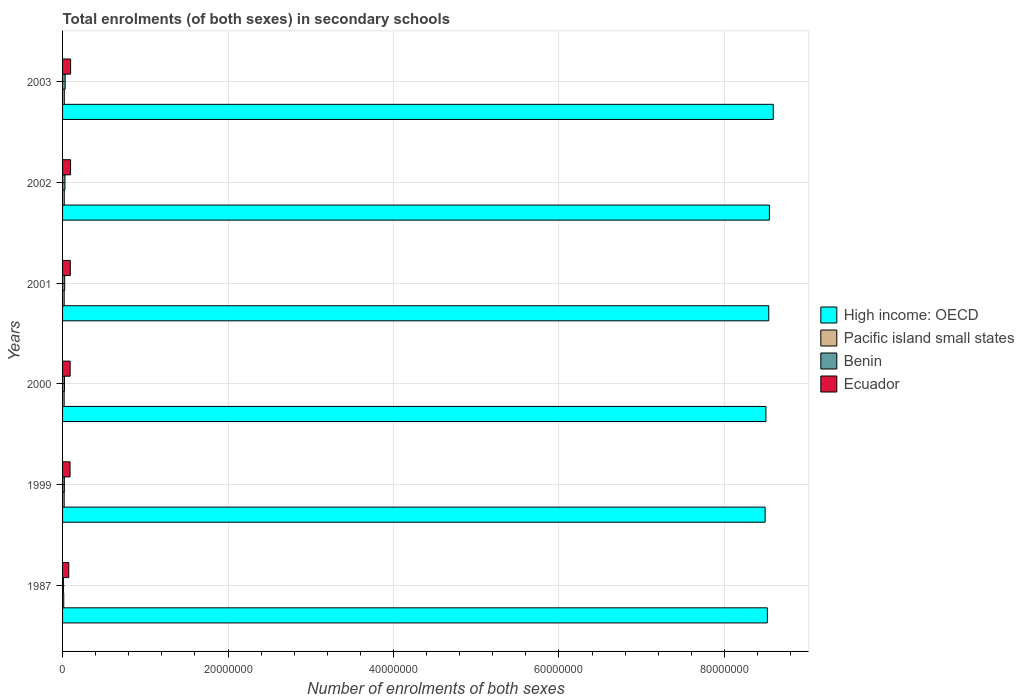How many different coloured bars are there?
Keep it short and to the point. 4. How many groups of bars are there?
Provide a short and direct response. 6. Are the number of bars on each tick of the Y-axis equal?
Give a very brief answer. Yes. How many bars are there on the 6th tick from the top?
Give a very brief answer. 4. How many bars are there on the 6th tick from the bottom?
Offer a terse response. 4. What is the label of the 6th group of bars from the top?
Give a very brief answer. 1987. What is the number of enrolments in secondary schools in Ecuador in 2003?
Ensure brevity in your answer.  9.73e+05. Across all years, what is the maximum number of enrolments in secondary schools in Pacific island small states?
Provide a short and direct response. 2.08e+05. Across all years, what is the minimum number of enrolments in secondary schools in Benin?
Make the answer very short. 1.02e+05. What is the total number of enrolments in secondary schools in Pacific island small states in the graph?
Make the answer very short. 1.13e+06. What is the difference between the number of enrolments in secondary schools in Pacific island small states in 1987 and that in 2003?
Keep it short and to the point. -6.49e+04. What is the difference between the number of enrolments in secondary schools in High income: OECD in 2001 and the number of enrolments in secondary schools in Ecuador in 2003?
Provide a succinct answer. 8.44e+07. What is the average number of enrolments in secondary schools in Benin per year?
Offer a very short reply. 2.34e+05. In the year 2000, what is the difference between the number of enrolments in secondary schools in Ecuador and number of enrolments in secondary schools in Pacific island small states?
Provide a short and direct response. 7.27e+05. What is the ratio of the number of enrolments in secondary schools in Benin in 2002 to that in 2003?
Provide a succinct answer. 0.92. Is the number of enrolments in secondary schools in Benin in 1987 less than that in 2000?
Ensure brevity in your answer.  Yes. What is the difference between the highest and the second highest number of enrolments in secondary schools in High income: OECD?
Make the answer very short. 4.66e+05. What is the difference between the highest and the lowest number of enrolments in secondary schools in High income: OECD?
Offer a very short reply. 9.82e+05. In how many years, is the number of enrolments in secondary schools in Pacific island small states greater than the average number of enrolments in secondary schools in Pacific island small states taken over all years?
Ensure brevity in your answer.  5. Is the sum of the number of enrolments in secondary schools in Ecuador in 2000 and 2001 greater than the maximum number of enrolments in secondary schools in Pacific island small states across all years?
Give a very brief answer. Yes. What does the 3rd bar from the top in 2001 represents?
Provide a short and direct response. Pacific island small states. What does the 1st bar from the bottom in 2000 represents?
Give a very brief answer. High income: OECD. Are all the bars in the graph horizontal?
Your answer should be very brief. Yes. How many years are there in the graph?
Ensure brevity in your answer.  6. How are the legend labels stacked?
Provide a succinct answer. Vertical. What is the title of the graph?
Offer a very short reply. Total enrolments (of both sexes) in secondary schools. What is the label or title of the X-axis?
Provide a short and direct response. Number of enrolments of both sexes. What is the Number of enrolments of both sexes of High income: OECD in 1987?
Your response must be concise. 8.52e+07. What is the Number of enrolments of both sexes of Pacific island small states in 1987?
Your answer should be compact. 1.43e+05. What is the Number of enrolments of both sexes of Benin in 1987?
Give a very brief answer. 1.02e+05. What is the Number of enrolments of both sexes in Ecuador in 1987?
Make the answer very short. 7.50e+05. What is the Number of enrolments of both sexes in High income: OECD in 1999?
Provide a short and direct response. 8.49e+07. What is the Number of enrolments of both sexes of Pacific island small states in 1999?
Your answer should be compact. 1.93e+05. What is the Number of enrolments of both sexes in Benin in 1999?
Provide a succinct answer. 2.13e+05. What is the Number of enrolments of both sexes of Ecuador in 1999?
Your answer should be very brief. 9.04e+05. What is the Number of enrolments of both sexes of High income: OECD in 2000?
Ensure brevity in your answer.  8.50e+07. What is the Number of enrolments of both sexes in Pacific island small states in 2000?
Provide a short and direct response. 1.91e+05. What is the Number of enrolments of both sexes of Benin in 2000?
Provide a succinct answer. 2.29e+05. What is the Number of enrolments of both sexes in Ecuador in 2000?
Provide a short and direct response. 9.17e+05. What is the Number of enrolments of both sexes in High income: OECD in 2001?
Keep it short and to the point. 8.54e+07. What is the Number of enrolments of both sexes of Pacific island small states in 2001?
Provide a succinct answer. 1.94e+05. What is the Number of enrolments of both sexes of Benin in 2001?
Your answer should be very brief. 2.57e+05. What is the Number of enrolments of both sexes in Ecuador in 2001?
Provide a short and direct response. 9.36e+05. What is the Number of enrolments of both sexes in High income: OECD in 2002?
Your response must be concise. 8.54e+07. What is the Number of enrolments of both sexes in Pacific island small states in 2002?
Your response must be concise. 2.03e+05. What is the Number of enrolments of both sexes of Benin in 2002?
Provide a short and direct response. 2.87e+05. What is the Number of enrolments of both sexes in Ecuador in 2002?
Offer a terse response. 9.66e+05. What is the Number of enrolments of both sexes in High income: OECD in 2003?
Provide a succinct answer. 8.59e+07. What is the Number of enrolments of both sexes in Pacific island small states in 2003?
Your response must be concise. 2.08e+05. What is the Number of enrolments of both sexes of Benin in 2003?
Your answer should be very brief. 3.12e+05. What is the Number of enrolments of both sexes in Ecuador in 2003?
Offer a terse response. 9.73e+05. Across all years, what is the maximum Number of enrolments of both sexes of High income: OECD?
Ensure brevity in your answer.  8.59e+07. Across all years, what is the maximum Number of enrolments of both sexes of Pacific island small states?
Your answer should be compact. 2.08e+05. Across all years, what is the maximum Number of enrolments of both sexes in Benin?
Offer a terse response. 3.12e+05. Across all years, what is the maximum Number of enrolments of both sexes of Ecuador?
Offer a very short reply. 9.73e+05. Across all years, what is the minimum Number of enrolments of both sexes in High income: OECD?
Offer a terse response. 8.49e+07. Across all years, what is the minimum Number of enrolments of both sexes in Pacific island small states?
Give a very brief answer. 1.43e+05. Across all years, what is the minimum Number of enrolments of both sexes of Benin?
Make the answer very short. 1.02e+05. Across all years, what is the minimum Number of enrolments of both sexes in Ecuador?
Your response must be concise. 7.50e+05. What is the total Number of enrolments of both sexes of High income: OECD in the graph?
Make the answer very short. 5.12e+08. What is the total Number of enrolments of both sexes of Pacific island small states in the graph?
Give a very brief answer. 1.13e+06. What is the total Number of enrolments of both sexes of Benin in the graph?
Provide a short and direct response. 1.40e+06. What is the total Number of enrolments of both sexes of Ecuador in the graph?
Your answer should be very brief. 5.45e+06. What is the difference between the Number of enrolments of both sexes of High income: OECD in 1987 and that in 1999?
Offer a very short reply. 2.66e+05. What is the difference between the Number of enrolments of both sexes of Pacific island small states in 1987 and that in 1999?
Ensure brevity in your answer.  -5.00e+04. What is the difference between the Number of enrolments of both sexes in Benin in 1987 and that in 1999?
Keep it short and to the point. -1.11e+05. What is the difference between the Number of enrolments of both sexes in Ecuador in 1987 and that in 1999?
Your answer should be very brief. -1.54e+05. What is the difference between the Number of enrolments of both sexes of High income: OECD in 1987 and that in 2000?
Provide a short and direct response. 1.71e+05. What is the difference between the Number of enrolments of both sexes in Pacific island small states in 1987 and that in 2000?
Your answer should be very brief. -4.80e+04. What is the difference between the Number of enrolments of both sexes in Benin in 1987 and that in 2000?
Offer a very short reply. -1.27e+05. What is the difference between the Number of enrolments of both sexes in Ecuador in 1987 and that in 2000?
Ensure brevity in your answer.  -1.67e+05. What is the difference between the Number of enrolments of both sexes of High income: OECD in 1987 and that in 2001?
Your answer should be very brief. -1.72e+05. What is the difference between the Number of enrolments of both sexes of Pacific island small states in 1987 and that in 2001?
Your answer should be very brief. -5.18e+04. What is the difference between the Number of enrolments of both sexes in Benin in 1987 and that in 2001?
Offer a terse response. -1.55e+05. What is the difference between the Number of enrolments of both sexes in Ecuador in 1987 and that in 2001?
Keep it short and to the point. -1.86e+05. What is the difference between the Number of enrolments of both sexes of High income: OECD in 1987 and that in 2002?
Ensure brevity in your answer.  -2.49e+05. What is the difference between the Number of enrolments of both sexes in Pacific island small states in 1987 and that in 2002?
Provide a succinct answer. -6.06e+04. What is the difference between the Number of enrolments of both sexes of Benin in 1987 and that in 2002?
Your answer should be compact. -1.85e+05. What is the difference between the Number of enrolments of both sexes in Ecuador in 1987 and that in 2002?
Provide a short and direct response. -2.16e+05. What is the difference between the Number of enrolments of both sexes in High income: OECD in 1987 and that in 2003?
Ensure brevity in your answer.  -7.16e+05. What is the difference between the Number of enrolments of both sexes of Pacific island small states in 1987 and that in 2003?
Keep it short and to the point. -6.49e+04. What is the difference between the Number of enrolments of both sexes in Benin in 1987 and that in 2003?
Provide a succinct answer. -2.10e+05. What is the difference between the Number of enrolments of both sexes of Ecuador in 1987 and that in 2003?
Give a very brief answer. -2.23e+05. What is the difference between the Number of enrolments of both sexes of High income: OECD in 1999 and that in 2000?
Provide a succinct answer. -9.49e+04. What is the difference between the Number of enrolments of both sexes in Pacific island small states in 1999 and that in 2000?
Provide a short and direct response. 1919. What is the difference between the Number of enrolments of both sexes of Benin in 1999 and that in 2000?
Make the answer very short. -1.58e+04. What is the difference between the Number of enrolments of both sexes of Ecuador in 1999 and that in 2000?
Make the answer very short. -1.37e+04. What is the difference between the Number of enrolments of both sexes of High income: OECD in 1999 and that in 2001?
Provide a short and direct response. -4.38e+05. What is the difference between the Number of enrolments of both sexes in Pacific island small states in 1999 and that in 2001?
Keep it short and to the point. -1878.09. What is the difference between the Number of enrolments of both sexes of Benin in 1999 and that in 2001?
Provide a short and direct response. -4.33e+04. What is the difference between the Number of enrolments of both sexes in Ecuador in 1999 and that in 2001?
Your answer should be very brief. -3.28e+04. What is the difference between the Number of enrolments of both sexes of High income: OECD in 1999 and that in 2002?
Provide a succinct answer. -5.15e+05. What is the difference between the Number of enrolments of both sexes of Pacific island small states in 1999 and that in 2002?
Give a very brief answer. -1.07e+04. What is the difference between the Number of enrolments of both sexes of Benin in 1999 and that in 2002?
Your answer should be very brief. -7.38e+04. What is the difference between the Number of enrolments of both sexes in Ecuador in 1999 and that in 2002?
Offer a terse response. -6.28e+04. What is the difference between the Number of enrolments of both sexes in High income: OECD in 1999 and that in 2003?
Your answer should be compact. -9.82e+05. What is the difference between the Number of enrolments of both sexes of Pacific island small states in 1999 and that in 2003?
Provide a succinct answer. -1.50e+04. What is the difference between the Number of enrolments of both sexes of Benin in 1999 and that in 2003?
Offer a very short reply. -9.90e+04. What is the difference between the Number of enrolments of both sexes of Ecuador in 1999 and that in 2003?
Offer a terse response. -6.92e+04. What is the difference between the Number of enrolments of both sexes in High income: OECD in 2000 and that in 2001?
Offer a terse response. -3.43e+05. What is the difference between the Number of enrolments of both sexes in Pacific island small states in 2000 and that in 2001?
Your answer should be very brief. -3797.09. What is the difference between the Number of enrolments of both sexes in Benin in 2000 and that in 2001?
Offer a terse response. -2.75e+04. What is the difference between the Number of enrolments of both sexes of Ecuador in 2000 and that in 2001?
Keep it short and to the point. -1.92e+04. What is the difference between the Number of enrolments of both sexes in High income: OECD in 2000 and that in 2002?
Make the answer very short. -4.20e+05. What is the difference between the Number of enrolments of both sexes of Pacific island small states in 2000 and that in 2002?
Make the answer very short. -1.26e+04. What is the difference between the Number of enrolments of both sexes in Benin in 2000 and that in 2002?
Make the answer very short. -5.81e+04. What is the difference between the Number of enrolments of both sexes of Ecuador in 2000 and that in 2002?
Provide a succinct answer. -4.91e+04. What is the difference between the Number of enrolments of both sexes in High income: OECD in 2000 and that in 2003?
Give a very brief answer. -8.87e+05. What is the difference between the Number of enrolments of both sexes in Pacific island small states in 2000 and that in 2003?
Give a very brief answer. -1.69e+04. What is the difference between the Number of enrolments of both sexes in Benin in 2000 and that in 2003?
Offer a very short reply. -8.32e+04. What is the difference between the Number of enrolments of both sexes in Ecuador in 2000 and that in 2003?
Ensure brevity in your answer.  -5.55e+04. What is the difference between the Number of enrolments of both sexes of High income: OECD in 2001 and that in 2002?
Provide a succinct answer. -7.73e+04. What is the difference between the Number of enrolments of both sexes in Pacific island small states in 2001 and that in 2002?
Provide a short and direct response. -8784.14. What is the difference between the Number of enrolments of both sexes in Benin in 2001 and that in 2002?
Your answer should be very brief. -3.05e+04. What is the difference between the Number of enrolments of both sexes in Ecuador in 2001 and that in 2002?
Make the answer very short. -3.00e+04. What is the difference between the Number of enrolments of both sexes of High income: OECD in 2001 and that in 2003?
Make the answer very short. -5.44e+05. What is the difference between the Number of enrolments of both sexes in Pacific island small states in 2001 and that in 2003?
Your answer should be compact. -1.31e+04. What is the difference between the Number of enrolments of both sexes in Benin in 2001 and that in 2003?
Your answer should be compact. -5.57e+04. What is the difference between the Number of enrolments of both sexes of Ecuador in 2001 and that in 2003?
Keep it short and to the point. -3.64e+04. What is the difference between the Number of enrolments of both sexes in High income: OECD in 2002 and that in 2003?
Offer a terse response. -4.66e+05. What is the difference between the Number of enrolments of both sexes of Pacific island small states in 2002 and that in 2003?
Offer a very short reply. -4304.56. What is the difference between the Number of enrolments of both sexes in Benin in 2002 and that in 2003?
Your response must be concise. -2.51e+04. What is the difference between the Number of enrolments of both sexes in Ecuador in 2002 and that in 2003?
Offer a very short reply. -6415. What is the difference between the Number of enrolments of both sexes of High income: OECD in 1987 and the Number of enrolments of both sexes of Pacific island small states in 1999?
Make the answer very short. 8.50e+07. What is the difference between the Number of enrolments of both sexes in High income: OECD in 1987 and the Number of enrolments of both sexes in Benin in 1999?
Your answer should be very brief. 8.50e+07. What is the difference between the Number of enrolments of both sexes in High income: OECD in 1987 and the Number of enrolments of both sexes in Ecuador in 1999?
Give a very brief answer. 8.43e+07. What is the difference between the Number of enrolments of both sexes in Pacific island small states in 1987 and the Number of enrolments of both sexes in Benin in 1999?
Your answer should be very brief. -7.09e+04. What is the difference between the Number of enrolments of both sexes in Pacific island small states in 1987 and the Number of enrolments of both sexes in Ecuador in 1999?
Your response must be concise. -7.61e+05. What is the difference between the Number of enrolments of both sexes of Benin in 1987 and the Number of enrolments of both sexes of Ecuador in 1999?
Give a very brief answer. -8.01e+05. What is the difference between the Number of enrolments of both sexes in High income: OECD in 1987 and the Number of enrolments of both sexes in Pacific island small states in 2000?
Ensure brevity in your answer.  8.50e+07. What is the difference between the Number of enrolments of both sexes of High income: OECD in 1987 and the Number of enrolments of both sexes of Benin in 2000?
Your answer should be compact. 8.50e+07. What is the difference between the Number of enrolments of both sexes of High income: OECD in 1987 and the Number of enrolments of both sexes of Ecuador in 2000?
Give a very brief answer. 8.43e+07. What is the difference between the Number of enrolments of both sexes in Pacific island small states in 1987 and the Number of enrolments of both sexes in Benin in 2000?
Make the answer very short. -8.66e+04. What is the difference between the Number of enrolments of both sexes of Pacific island small states in 1987 and the Number of enrolments of both sexes of Ecuador in 2000?
Your answer should be compact. -7.75e+05. What is the difference between the Number of enrolments of both sexes of Benin in 1987 and the Number of enrolments of both sexes of Ecuador in 2000?
Give a very brief answer. -8.15e+05. What is the difference between the Number of enrolments of both sexes of High income: OECD in 1987 and the Number of enrolments of both sexes of Pacific island small states in 2001?
Offer a very short reply. 8.50e+07. What is the difference between the Number of enrolments of both sexes of High income: OECD in 1987 and the Number of enrolments of both sexes of Benin in 2001?
Ensure brevity in your answer.  8.49e+07. What is the difference between the Number of enrolments of both sexes in High income: OECD in 1987 and the Number of enrolments of both sexes in Ecuador in 2001?
Ensure brevity in your answer.  8.43e+07. What is the difference between the Number of enrolments of both sexes in Pacific island small states in 1987 and the Number of enrolments of both sexes in Benin in 2001?
Your response must be concise. -1.14e+05. What is the difference between the Number of enrolments of both sexes of Pacific island small states in 1987 and the Number of enrolments of both sexes of Ecuador in 2001?
Offer a terse response. -7.94e+05. What is the difference between the Number of enrolments of both sexes in Benin in 1987 and the Number of enrolments of both sexes in Ecuador in 2001?
Offer a very short reply. -8.34e+05. What is the difference between the Number of enrolments of both sexes of High income: OECD in 1987 and the Number of enrolments of both sexes of Pacific island small states in 2002?
Make the answer very short. 8.50e+07. What is the difference between the Number of enrolments of both sexes in High income: OECD in 1987 and the Number of enrolments of both sexes in Benin in 2002?
Your response must be concise. 8.49e+07. What is the difference between the Number of enrolments of both sexes in High income: OECD in 1987 and the Number of enrolments of both sexes in Ecuador in 2002?
Make the answer very short. 8.42e+07. What is the difference between the Number of enrolments of both sexes of Pacific island small states in 1987 and the Number of enrolments of both sexes of Benin in 2002?
Provide a succinct answer. -1.45e+05. What is the difference between the Number of enrolments of both sexes in Pacific island small states in 1987 and the Number of enrolments of both sexes in Ecuador in 2002?
Give a very brief answer. -8.24e+05. What is the difference between the Number of enrolments of both sexes in Benin in 1987 and the Number of enrolments of both sexes in Ecuador in 2002?
Ensure brevity in your answer.  -8.64e+05. What is the difference between the Number of enrolments of both sexes of High income: OECD in 1987 and the Number of enrolments of both sexes of Pacific island small states in 2003?
Offer a terse response. 8.50e+07. What is the difference between the Number of enrolments of both sexes of High income: OECD in 1987 and the Number of enrolments of both sexes of Benin in 2003?
Your answer should be compact. 8.49e+07. What is the difference between the Number of enrolments of both sexes of High income: OECD in 1987 and the Number of enrolments of both sexes of Ecuador in 2003?
Your response must be concise. 8.42e+07. What is the difference between the Number of enrolments of both sexes in Pacific island small states in 1987 and the Number of enrolments of both sexes in Benin in 2003?
Provide a succinct answer. -1.70e+05. What is the difference between the Number of enrolments of both sexes of Pacific island small states in 1987 and the Number of enrolments of both sexes of Ecuador in 2003?
Provide a succinct answer. -8.30e+05. What is the difference between the Number of enrolments of both sexes of Benin in 1987 and the Number of enrolments of both sexes of Ecuador in 2003?
Make the answer very short. -8.71e+05. What is the difference between the Number of enrolments of both sexes of High income: OECD in 1999 and the Number of enrolments of both sexes of Pacific island small states in 2000?
Offer a very short reply. 8.47e+07. What is the difference between the Number of enrolments of both sexes in High income: OECD in 1999 and the Number of enrolments of both sexes in Benin in 2000?
Your answer should be compact. 8.47e+07. What is the difference between the Number of enrolments of both sexes in High income: OECD in 1999 and the Number of enrolments of both sexes in Ecuador in 2000?
Keep it short and to the point. 8.40e+07. What is the difference between the Number of enrolments of both sexes in Pacific island small states in 1999 and the Number of enrolments of both sexes in Benin in 2000?
Your answer should be compact. -3.66e+04. What is the difference between the Number of enrolments of both sexes of Pacific island small states in 1999 and the Number of enrolments of both sexes of Ecuador in 2000?
Offer a very short reply. -7.25e+05. What is the difference between the Number of enrolments of both sexes in Benin in 1999 and the Number of enrolments of both sexes in Ecuador in 2000?
Give a very brief answer. -7.04e+05. What is the difference between the Number of enrolments of both sexes of High income: OECD in 1999 and the Number of enrolments of both sexes of Pacific island small states in 2001?
Offer a terse response. 8.47e+07. What is the difference between the Number of enrolments of both sexes of High income: OECD in 1999 and the Number of enrolments of both sexes of Benin in 2001?
Keep it short and to the point. 8.47e+07. What is the difference between the Number of enrolments of both sexes in High income: OECD in 1999 and the Number of enrolments of both sexes in Ecuador in 2001?
Your response must be concise. 8.40e+07. What is the difference between the Number of enrolments of both sexes of Pacific island small states in 1999 and the Number of enrolments of both sexes of Benin in 2001?
Offer a terse response. -6.42e+04. What is the difference between the Number of enrolments of both sexes in Pacific island small states in 1999 and the Number of enrolments of both sexes in Ecuador in 2001?
Your answer should be very brief. -7.44e+05. What is the difference between the Number of enrolments of both sexes in Benin in 1999 and the Number of enrolments of both sexes in Ecuador in 2001?
Your answer should be compact. -7.23e+05. What is the difference between the Number of enrolments of both sexes in High income: OECD in 1999 and the Number of enrolments of both sexes in Pacific island small states in 2002?
Provide a succinct answer. 8.47e+07. What is the difference between the Number of enrolments of both sexes of High income: OECD in 1999 and the Number of enrolments of both sexes of Benin in 2002?
Make the answer very short. 8.46e+07. What is the difference between the Number of enrolments of both sexes of High income: OECD in 1999 and the Number of enrolments of both sexes of Ecuador in 2002?
Your answer should be very brief. 8.40e+07. What is the difference between the Number of enrolments of both sexes of Pacific island small states in 1999 and the Number of enrolments of both sexes of Benin in 2002?
Make the answer very short. -9.47e+04. What is the difference between the Number of enrolments of both sexes of Pacific island small states in 1999 and the Number of enrolments of both sexes of Ecuador in 2002?
Give a very brief answer. -7.74e+05. What is the difference between the Number of enrolments of both sexes in Benin in 1999 and the Number of enrolments of both sexes in Ecuador in 2002?
Give a very brief answer. -7.53e+05. What is the difference between the Number of enrolments of both sexes of High income: OECD in 1999 and the Number of enrolments of both sexes of Pacific island small states in 2003?
Make the answer very short. 8.47e+07. What is the difference between the Number of enrolments of both sexes of High income: OECD in 1999 and the Number of enrolments of both sexes of Benin in 2003?
Give a very brief answer. 8.46e+07. What is the difference between the Number of enrolments of both sexes in High income: OECD in 1999 and the Number of enrolments of both sexes in Ecuador in 2003?
Make the answer very short. 8.39e+07. What is the difference between the Number of enrolments of both sexes of Pacific island small states in 1999 and the Number of enrolments of both sexes of Benin in 2003?
Keep it short and to the point. -1.20e+05. What is the difference between the Number of enrolments of both sexes of Pacific island small states in 1999 and the Number of enrolments of both sexes of Ecuador in 2003?
Your answer should be very brief. -7.80e+05. What is the difference between the Number of enrolments of both sexes of Benin in 1999 and the Number of enrolments of both sexes of Ecuador in 2003?
Your answer should be compact. -7.59e+05. What is the difference between the Number of enrolments of both sexes in High income: OECD in 2000 and the Number of enrolments of both sexes in Pacific island small states in 2001?
Ensure brevity in your answer.  8.48e+07. What is the difference between the Number of enrolments of both sexes of High income: OECD in 2000 and the Number of enrolments of both sexes of Benin in 2001?
Ensure brevity in your answer.  8.48e+07. What is the difference between the Number of enrolments of both sexes of High income: OECD in 2000 and the Number of enrolments of both sexes of Ecuador in 2001?
Give a very brief answer. 8.41e+07. What is the difference between the Number of enrolments of both sexes in Pacific island small states in 2000 and the Number of enrolments of both sexes in Benin in 2001?
Provide a succinct answer. -6.61e+04. What is the difference between the Number of enrolments of both sexes in Pacific island small states in 2000 and the Number of enrolments of both sexes in Ecuador in 2001?
Your response must be concise. -7.46e+05. What is the difference between the Number of enrolments of both sexes of Benin in 2000 and the Number of enrolments of both sexes of Ecuador in 2001?
Provide a succinct answer. -7.07e+05. What is the difference between the Number of enrolments of both sexes of High income: OECD in 2000 and the Number of enrolments of both sexes of Pacific island small states in 2002?
Give a very brief answer. 8.48e+07. What is the difference between the Number of enrolments of both sexes in High income: OECD in 2000 and the Number of enrolments of both sexes in Benin in 2002?
Your answer should be very brief. 8.47e+07. What is the difference between the Number of enrolments of both sexes of High income: OECD in 2000 and the Number of enrolments of both sexes of Ecuador in 2002?
Make the answer very short. 8.41e+07. What is the difference between the Number of enrolments of both sexes in Pacific island small states in 2000 and the Number of enrolments of both sexes in Benin in 2002?
Offer a very short reply. -9.66e+04. What is the difference between the Number of enrolments of both sexes in Pacific island small states in 2000 and the Number of enrolments of both sexes in Ecuador in 2002?
Your answer should be compact. -7.76e+05. What is the difference between the Number of enrolments of both sexes in Benin in 2000 and the Number of enrolments of both sexes in Ecuador in 2002?
Give a very brief answer. -7.37e+05. What is the difference between the Number of enrolments of both sexes in High income: OECD in 2000 and the Number of enrolments of both sexes in Pacific island small states in 2003?
Provide a short and direct response. 8.48e+07. What is the difference between the Number of enrolments of both sexes in High income: OECD in 2000 and the Number of enrolments of both sexes in Benin in 2003?
Your answer should be very brief. 8.47e+07. What is the difference between the Number of enrolments of both sexes of High income: OECD in 2000 and the Number of enrolments of both sexes of Ecuador in 2003?
Offer a terse response. 8.40e+07. What is the difference between the Number of enrolments of both sexes of Pacific island small states in 2000 and the Number of enrolments of both sexes of Benin in 2003?
Give a very brief answer. -1.22e+05. What is the difference between the Number of enrolments of both sexes of Pacific island small states in 2000 and the Number of enrolments of both sexes of Ecuador in 2003?
Your answer should be very brief. -7.82e+05. What is the difference between the Number of enrolments of both sexes of Benin in 2000 and the Number of enrolments of both sexes of Ecuador in 2003?
Provide a short and direct response. -7.44e+05. What is the difference between the Number of enrolments of both sexes in High income: OECD in 2001 and the Number of enrolments of both sexes in Pacific island small states in 2002?
Provide a succinct answer. 8.52e+07. What is the difference between the Number of enrolments of both sexes in High income: OECD in 2001 and the Number of enrolments of both sexes in Benin in 2002?
Your answer should be compact. 8.51e+07. What is the difference between the Number of enrolments of both sexes in High income: OECD in 2001 and the Number of enrolments of both sexes in Ecuador in 2002?
Provide a short and direct response. 8.44e+07. What is the difference between the Number of enrolments of both sexes of Pacific island small states in 2001 and the Number of enrolments of both sexes of Benin in 2002?
Ensure brevity in your answer.  -9.28e+04. What is the difference between the Number of enrolments of both sexes of Pacific island small states in 2001 and the Number of enrolments of both sexes of Ecuador in 2002?
Ensure brevity in your answer.  -7.72e+05. What is the difference between the Number of enrolments of both sexes of Benin in 2001 and the Number of enrolments of both sexes of Ecuador in 2002?
Offer a terse response. -7.10e+05. What is the difference between the Number of enrolments of both sexes of High income: OECD in 2001 and the Number of enrolments of both sexes of Pacific island small states in 2003?
Your answer should be very brief. 8.52e+07. What is the difference between the Number of enrolments of both sexes in High income: OECD in 2001 and the Number of enrolments of both sexes in Benin in 2003?
Give a very brief answer. 8.50e+07. What is the difference between the Number of enrolments of both sexes in High income: OECD in 2001 and the Number of enrolments of both sexes in Ecuador in 2003?
Provide a succinct answer. 8.44e+07. What is the difference between the Number of enrolments of both sexes in Pacific island small states in 2001 and the Number of enrolments of both sexes in Benin in 2003?
Provide a succinct answer. -1.18e+05. What is the difference between the Number of enrolments of both sexes of Pacific island small states in 2001 and the Number of enrolments of both sexes of Ecuador in 2003?
Offer a very short reply. -7.78e+05. What is the difference between the Number of enrolments of both sexes of Benin in 2001 and the Number of enrolments of both sexes of Ecuador in 2003?
Your answer should be very brief. -7.16e+05. What is the difference between the Number of enrolments of both sexes in High income: OECD in 2002 and the Number of enrolments of both sexes in Pacific island small states in 2003?
Ensure brevity in your answer.  8.52e+07. What is the difference between the Number of enrolments of both sexes of High income: OECD in 2002 and the Number of enrolments of both sexes of Benin in 2003?
Your response must be concise. 8.51e+07. What is the difference between the Number of enrolments of both sexes in High income: OECD in 2002 and the Number of enrolments of both sexes in Ecuador in 2003?
Offer a very short reply. 8.45e+07. What is the difference between the Number of enrolments of both sexes of Pacific island small states in 2002 and the Number of enrolments of both sexes of Benin in 2003?
Your answer should be compact. -1.09e+05. What is the difference between the Number of enrolments of both sexes in Pacific island small states in 2002 and the Number of enrolments of both sexes in Ecuador in 2003?
Ensure brevity in your answer.  -7.70e+05. What is the difference between the Number of enrolments of both sexes in Benin in 2002 and the Number of enrolments of both sexes in Ecuador in 2003?
Your response must be concise. -6.85e+05. What is the average Number of enrolments of both sexes of High income: OECD per year?
Make the answer very short. 8.53e+07. What is the average Number of enrolments of both sexes of Pacific island small states per year?
Offer a terse response. 1.89e+05. What is the average Number of enrolments of both sexes of Benin per year?
Your answer should be very brief. 2.34e+05. What is the average Number of enrolments of both sexes in Ecuador per year?
Ensure brevity in your answer.  9.08e+05. In the year 1987, what is the difference between the Number of enrolments of both sexes in High income: OECD and Number of enrolments of both sexes in Pacific island small states?
Make the answer very short. 8.50e+07. In the year 1987, what is the difference between the Number of enrolments of both sexes of High income: OECD and Number of enrolments of both sexes of Benin?
Give a very brief answer. 8.51e+07. In the year 1987, what is the difference between the Number of enrolments of both sexes of High income: OECD and Number of enrolments of both sexes of Ecuador?
Offer a terse response. 8.44e+07. In the year 1987, what is the difference between the Number of enrolments of both sexes in Pacific island small states and Number of enrolments of both sexes in Benin?
Provide a succinct answer. 4.04e+04. In the year 1987, what is the difference between the Number of enrolments of both sexes in Pacific island small states and Number of enrolments of both sexes in Ecuador?
Ensure brevity in your answer.  -6.07e+05. In the year 1987, what is the difference between the Number of enrolments of both sexes in Benin and Number of enrolments of both sexes in Ecuador?
Give a very brief answer. -6.48e+05. In the year 1999, what is the difference between the Number of enrolments of both sexes of High income: OECD and Number of enrolments of both sexes of Pacific island small states?
Provide a short and direct response. 8.47e+07. In the year 1999, what is the difference between the Number of enrolments of both sexes in High income: OECD and Number of enrolments of both sexes in Benin?
Keep it short and to the point. 8.47e+07. In the year 1999, what is the difference between the Number of enrolments of both sexes in High income: OECD and Number of enrolments of both sexes in Ecuador?
Make the answer very short. 8.40e+07. In the year 1999, what is the difference between the Number of enrolments of both sexes in Pacific island small states and Number of enrolments of both sexes in Benin?
Make the answer very short. -2.09e+04. In the year 1999, what is the difference between the Number of enrolments of both sexes of Pacific island small states and Number of enrolments of both sexes of Ecuador?
Offer a terse response. -7.11e+05. In the year 1999, what is the difference between the Number of enrolments of both sexes of Benin and Number of enrolments of both sexes of Ecuador?
Offer a terse response. -6.90e+05. In the year 2000, what is the difference between the Number of enrolments of both sexes of High income: OECD and Number of enrolments of both sexes of Pacific island small states?
Offer a terse response. 8.48e+07. In the year 2000, what is the difference between the Number of enrolments of both sexes in High income: OECD and Number of enrolments of both sexes in Benin?
Keep it short and to the point. 8.48e+07. In the year 2000, what is the difference between the Number of enrolments of both sexes in High income: OECD and Number of enrolments of both sexes in Ecuador?
Ensure brevity in your answer.  8.41e+07. In the year 2000, what is the difference between the Number of enrolments of both sexes of Pacific island small states and Number of enrolments of both sexes of Benin?
Ensure brevity in your answer.  -3.86e+04. In the year 2000, what is the difference between the Number of enrolments of both sexes in Pacific island small states and Number of enrolments of both sexes in Ecuador?
Offer a terse response. -7.27e+05. In the year 2000, what is the difference between the Number of enrolments of both sexes of Benin and Number of enrolments of both sexes of Ecuador?
Offer a very short reply. -6.88e+05. In the year 2001, what is the difference between the Number of enrolments of both sexes in High income: OECD and Number of enrolments of both sexes in Pacific island small states?
Provide a succinct answer. 8.52e+07. In the year 2001, what is the difference between the Number of enrolments of both sexes in High income: OECD and Number of enrolments of both sexes in Benin?
Provide a short and direct response. 8.51e+07. In the year 2001, what is the difference between the Number of enrolments of both sexes in High income: OECD and Number of enrolments of both sexes in Ecuador?
Give a very brief answer. 8.44e+07. In the year 2001, what is the difference between the Number of enrolments of both sexes in Pacific island small states and Number of enrolments of both sexes in Benin?
Provide a succinct answer. -6.23e+04. In the year 2001, what is the difference between the Number of enrolments of both sexes in Pacific island small states and Number of enrolments of both sexes in Ecuador?
Give a very brief answer. -7.42e+05. In the year 2001, what is the difference between the Number of enrolments of both sexes in Benin and Number of enrolments of both sexes in Ecuador?
Keep it short and to the point. -6.80e+05. In the year 2002, what is the difference between the Number of enrolments of both sexes in High income: OECD and Number of enrolments of both sexes in Pacific island small states?
Offer a terse response. 8.52e+07. In the year 2002, what is the difference between the Number of enrolments of both sexes of High income: OECD and Number of enrolments of both sexes of Benin?
Your answer should be compact. 8.51e+07. In the year 2002, what is the difference between the Number of enrolments of both sexes of High income: OECD and Number of enrolments of both sexes of Ecuador?
Make the answer very short. 8.45e+07. In the year 2002, what is the difference between the Number of enrolments of both sexes of Pacific island small states and Number of enrolments of both sexes of Benin?
Ensure brevity in your answer.  -8.40e+04. In the year 2002, what is the difference between the Number of enrolments of both sexes in Pacific island small states and Number of enrolments of both sexes in Ecuador?
Offer a very short reply. -7.63e+05. In the year 2002, what is the difference between the Number of enrolments of both sexes in Benin and Number of enrolments of both sexes in Ecuador?
Your answer should be very brief. -6.79e+05. In the year 2003, what is the difference between the Number of enrolments of both sexes of High income: OECD and Number of enrolments of both sexes of Pacific island small states?
Offer a terse response. 8.57e+07. In the year 2003, what is the difference between the Number of enrolments of both sexes of High income: OECD and Number of enrolments of both sexes of Benin?
Keep it short and to the point. 8.56e+07. In the year 2003, what is the difference between the Number of enrolments of both sexes of High income: OECD and Number of enrolments of both sexes of Ecuador?
Ensure brevity in your answer.  8.49e+07. In the year 2003, what is the difference between the Number of enrolments of both sexes in Pacific island small states and Number of enrolments of both sexes in Benin?
Make the answer very short. -1.05e+05. In the year 2003, what is the difference between the Number of enrolments of both sexes in Pacific island small states and Number of enrolments of both sexes in Ecuador?
Give a very brief answer. -7.65e+05. In the year 2003, what is the difference between the Number of enrolments of both sexes of Benin and Number of enrolments of both sexes of Ecuador?
Offer a terse response. -6.60e+05. What is the ratio of the Number of enrolments of both sexes in Pacific island small states in 1987 to that in 1999?
Offer a terse response. 0.74. What is the ratio of the Number of enrolments of both sexes in Benin in 1987 to that in 1999?
Your answer should be compact. 0.48. What is the ratio of the Number of enrolments of both sexes of Ecuador in 1987 to that in 1999?
Keep it short and to the point. 0.83. What is the ratio of the Number of enrolments of both sexes of High income: OECD in 1987 to that in 2000?
Your response must be concise. 1. What is the ratio of the Number of enrolments of both sexes of Pacific island small states in 1987 to that in 2000?
Make the answer very short. 0.75. What is the ratio of the Number of enrolments of both sexes of Benin in 1987 to that in 2000?
Ensure brevity in your answer.  0.45. What is the ratio of the Number of enrolments of both sexes of Ecuador in 1987 to that in 2000?
Keep it short and to the point. 0.82. What is the ratio of the Number of enrolments of both sexes in Pacific island small states in 1987 to that in 2001?
Your answer should be compact. 0.73. What is the ratio of the Number of enrolments of both sexes of Benin in 1987 to that in 2001?
Provide a succinct answer. 0.4. What is the ratio of the Number of enrolments of both sexes in Ecuador in 1987 to that in 2001?
Offer a very short reply. 0.8. What is the ratio of the Number of enrolments of both sexes of High income: OECD in 1987 to that in 2002?
Give a very brief answer. 1. What is the ratio of the Number of enrolments of both sexes of Pacific island small states in 1987 to that in 2002?
Provide a short and direct response. 0.7. What is the ratio of the Number of enrolments of both sexes in Benin in 1987 to that in 2002?
Provide a short and direct response. 0.36. What is the ratio of the Number of enrolments of both sexes in Ecuador in 1987 to that in 2002?
Offer a very short reply. 0.78. What is the ratio of the Number of enrolments of both sexes in Pacific island small states in 1987 to that in 2003?
Give a very brief answer. 0.69. What is the ratio of the Number of enrolments of both sexes of Benin in 1987 to that in 2003?
Ensure brevity in your answer.  0.33. What is the ratio of the Number of enrolments of both sexes in Ecuador in 1987 to that in 2003?
Offer a very short reply. 0.77. What is the ratio of the Number of enrolments of both sexes of High income: OECD in 1999 to that in 2000?
Your response must be concise. 1. What is the ratio of the Number of enrolments of both sexes in Benin in 1999 to that in 2000?
Keep it short and to the point. 0.93. What is the ratio of the Number of enrolments of both sexes of Ecuador in 1999 to that in 2000?
Give a very brief answer. 0.99. What is the ratio of the Number of enrolments of both sexes in Pacific island small states in 1999 to that in 2001?
Ensure brevity in your answer.  0.99. What is the ratio of the Number of enrolments of both sexes in Benin in 1999 to that in 2001?
Offer a terse response. 0.83. What is the ratio of the Number of enrolments of both sexes of Ecuador in 1999 to that in 2001?
Give a very brief answer. 0.96. What is the ratio of the Number of enrolments of both sexes in Pacific island small states in 1999 to that in 2002?
Provide a short and direct response. 0.95. What is the ratio of the Number of enrolments of both sexes of Benin in 1999 to that in 2002?
Provide a succinct answer. 0.74. What is the ratio of the Number of enrolments of both sexes in Ecuador in 1999 to that in 2002?
Keep it short and to the point. 0.94. What is the ratio of the Number of enrolments of both sexes in High income: OECD in 1999 to that in 2003?
Make the answer very short. 0.99. What is the ratio of the Number of enrolments of both sexes of Pacific island small states in 1999 to that in 2003?
Offer a terse response. 0.93. What is the ratio of the Number of enrolments of both sexes of Benin in 1999 to that in 2003?
Your answer should be very brief. 0.68. What is the ratio of the Number of enrolments of both sexes in Ecuador in 1999 to that in 2003?
Your answer should be very brief. 0.93. What is the ratio of the Number of enrolments of both sexes in Pacific island small states in 2000 to that in 2001?
Your answer should be compact. 0.98. What is the ratio of the Number of enrolments of both sexes of Benin in 2000 to that in 2001?
Give a very brief answer. 0.89. What is the ratio of the Number of enrolments of both sexes of Ecuador in 2000 to that in 2001?
Make the answer very short. 0.98. What is the ratio of the Number of enrolments of both sexes in High income: OECD in 2000 to that in 2002?
Your response must be concise. 1. What is the ratio of the Number of enrolments of both sexes in Pacific island small states in 2000 to that in 2002?
Offer a very short reply. 0.94. What is the ratio of the Number of enrolments of both sexes in Benin in 2000 to that in 2002?
Make the answer very short. 0.8. What is the ratio of the Number of enrolments of both sexes of Ecuador in 2000 to that in 2002?
Give a very brief answer. 0.95. What is the ratio of the Number of enrolments of both sexes of Pacific island small states in 2000 to that in 2003?
Keep it short and to the point. 0.92. What is the ratio of the Number of enrolments of both sexes of Benin in 2000 to that in 2003?
Your answer should be very brief. 0.73. What is the ratio of the Number of enrolments of both sexes of Ecuador in 2000 to that in 2003?
Offer a very short reply. 0.94. What is the ratio of the Number of enrolments of both sexes of High income: OECD in 2001 to that in 2002?
Offer a terse response. 1. What is the ratio of the Number of enrolments of both sexes of Pacific island small states in 2001 to that in 2002?
Provide a short and direct response. 0.96. What is the ratio of the Number of enrolments of both sexes of Benin in 2001 to that in 2002?
Keep it short and to the point. 0.89. What is the ratio of the Number of enrolments of both sexes in Pacific island small states in 2001 to that in 2003?
Your response must be concise. 0.94. What is the ratio of the Number of enrolments of both sexes of Benin in 2001 to that in 2003?
Your answer should be very brief. 0.82. What is the ratio of the Number of enrolments of both sexes of Ecuador in 2001 to that in 2003?
Your answer should be compact. 0.96. What is the ratio of the Number of enrolments of both sexes in High income: OECD in 2002 to that in 2003?
Keep it short and to the point. 0.99. What is the ratio of the Number of enrolments of both sexes of Pacific island small states in 2002 to that in 2003?
Provide a short and direct response. 0.98. What is the ratio of the Number of enrolments of both sexes in Benin in 2002 to that in 2003?
Offer a terse response. 0.92. What is the difference between the highest and the second highest Number of enrolments of both sexes of High income: OECD?
Offer a very short reply. 4.66e+05. What is the difference between the highest and the second highest Number of enrolments of both sexes in Pacific island small states?
Keep it short and to the point. 4304.56. What is the difference between the highest and the second highest Number of enrolments of both sexes in Benin?
Ensure brevity in your answer.  2.51e+04. What is the difference between the highest and the second highest Number of enrolments of both sexes in Ecuador?
Give a very brief answer. 6415. What is the difference between the highest and the lowest Number of enrolments of both sexes in High income: OECD?
Keep it short and to the point. 9.82e+05. What is the difference between the highest and the lowest Number of enrolments of both sexes of Pacific island small states?
Your answer should be compact. 6.49e+04. What is the difference between the highest and the lowest Number of enrolments of both sexes in Benin?
Make the answer very short. 2.10e+05. What is the difference between the highest and the lowest Number of enrolments of both sexes in Ecuador?
Make the answer very short. 2.23e+05. 